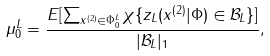<formula> <loc_0><loc_0><loc_500><loc_500>\mu ^ { L } _ { 0 } = \frac { E [ \sum _ { x ^ { ( 2 ) } \in \Phi ^ { L } _ { 0 } } \chi \{ z _ { L } ( x ^ { ( 2 ) } | \Phi ) \in \mathcal { B } _ { L } \} ] } { | \mathcal { B } _ { L } | _ { 1 } } ,</formula> 